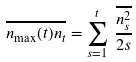Convert formula to latex. <formula><loc_0><loc_0><loc_500><loc_500>\overline { n _ { \max } ( t ) n _ { t } } = \sum ^ { t } _ { s = 1 } \, \frac { \overline { n _ { s } ^ { 2 } } } { 2 s }</formula> 